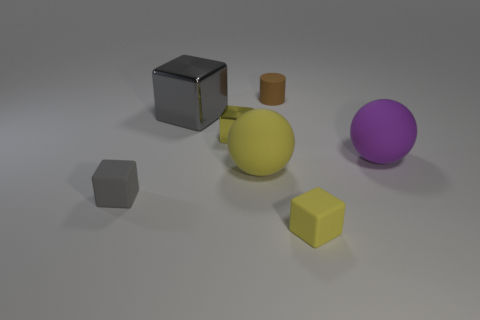There is a metal thing that is right of the big gray shiny cube; what shape is it?
Give a very brief answer. Cube. What is the color of the tiny rubber object that is on the left side of the large rubber thing that is on the left side of the brown rubber object?
Your answer should be very brief. Gray. Do the yellow matte thing that is behind the small gray matte cube and the yellow metal object that is on the left side of the purple rubber sphere have the same shape?
Your answer should be very brief. No. The brown thing that is the same size as the gray rubber cube is what shape?
Offer a terse response. Cylinder. What is the color of the cylinder that is made of the same material as the large yellow object?
Your answer should be very brief. Brown. There is a big yellow rubber thing; does it have the same shape as the small yellow object that is right of the yellow metallic object?
Your response must be concise. No. There is a small thing that is the same color as the small shiny cube; what material is it?
Your answer should be compact. Rubber. There is a gray block that is the same size as the brown cylinder; what is its material?
Offer a very short reply. Rubber. Is there a small shiny thing of the same color as the tiny metal cube?
Offer a terse response. No. The big object that is to the left of the small brown rubber cylinder and on the right side of the large block has what shape?
Your response must be concise. Sphere. 